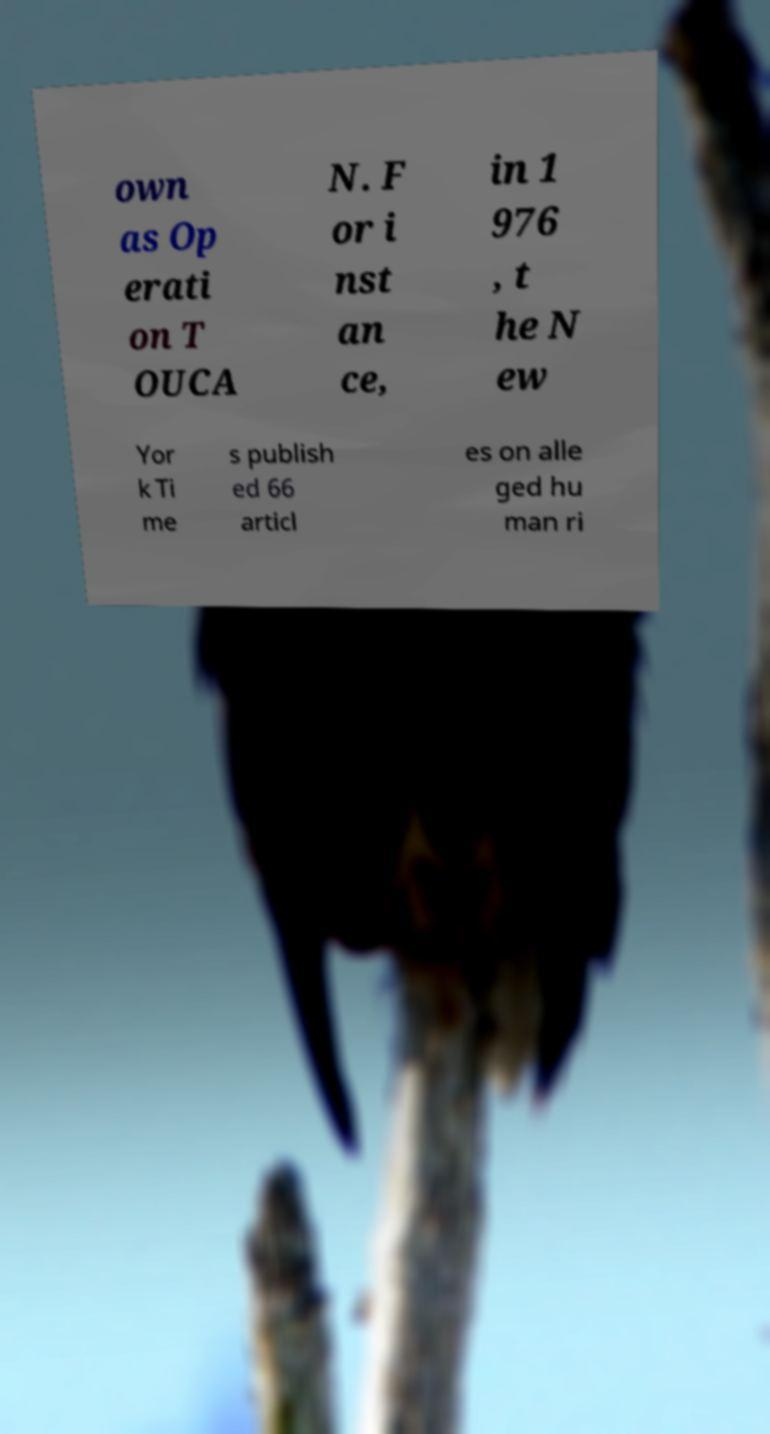Please identify and transcribe the text found in this image. own as Op erati on T OUCA N. F or i nst an ce, in 1 976 , t he N ew Yor k Ti me s publish ed 66 articl es on alle ged hu man ri 